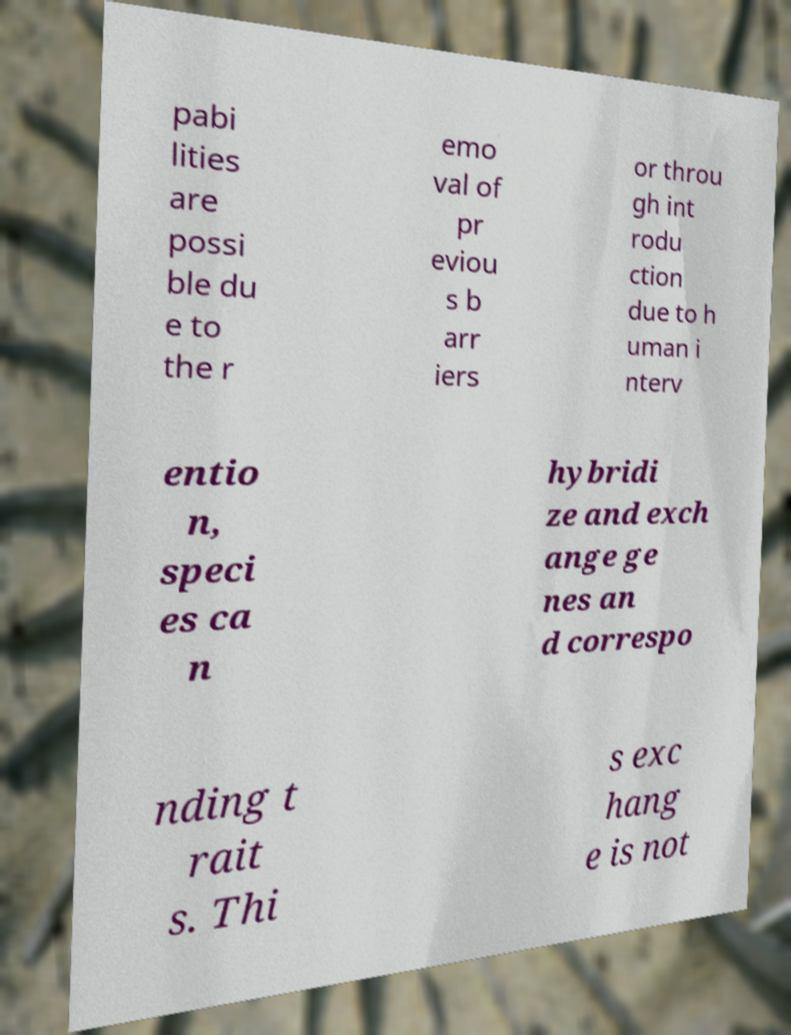Please identify and transcribe the text found in this image. pabi lities are possi ble du e to the r emo val of pr eviou s b arr iers or throu gh int rodu ction due to h uman i nterv entio n, speci es ca n hybridi ze and exch ange ge nes an d correspo nding t rait s. Thi s exc hang e is not 